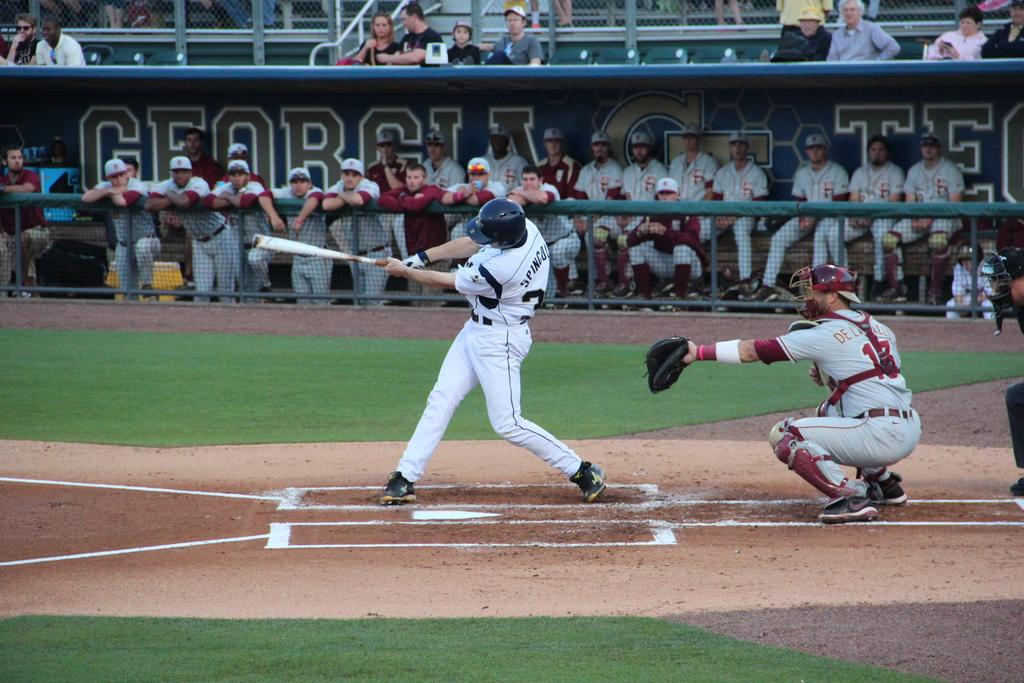<image>
Share a concise interpretation of the image provided. Many baseball players watch the game from the bench in front of a Georgia Tech banner. 